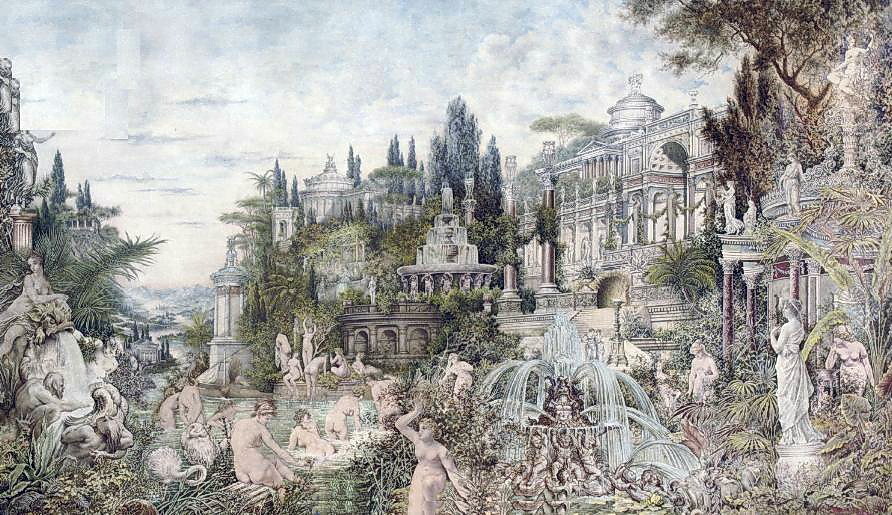What details in the image hint at its overall mood and atmosphere? Several elements in the image are integral in creating the overall mood and atmosphere. The soft pastel color palette, dominated by greens and blues, instills a sense of calm and serenity. The lush gardens, brimming with various plants and flowers, add to the tranquil and refreshing ambiance.

The presence of elaborately detailed statues and dynamic fountains introduces a sense of timeless elegance and refined artistry. The grand palace, with its intricate Rococo-style detailing, exudes majesty and opulence. Together, these components craft a scene that feels both peaceful and fantastical, encouraging viewers to lose themselves in its beauty and intricacy. What could be the historical context or background of such a palace and garden? The palace and garden depicted in the image could be inspired by European architectural and garden design traditions from the 18th century, particularly those associated with the Rococo and Baroque periods. During this era, grand palaces were constructed as symbols of royal or aristocratic power and wealth. These opulent residences were often surrounded by meticulously designed gardens that served as both personal retreats and venues for social gatherings.

Such estates were not only places of residence but also expressions of artistic and cultural sophistication. The extensive use of sculptures, fountains, and ornamental plants in the gardens reflects the era's fascination with classical art, mythology, and the harmonious blend of nature and human creativity. The palace itself, with its intricate design and elaborate decorations, exemplifies the Rococo style's emphasis on elegance, lightness, and ornamental beauty.

Historically, these settings were designed to impress and inspire awe, serving as embodiments of the owner's status and taste. They were often the backdrop for lavish events, intellectual salons, and private moments of contemplation, capturing the essence of a bygone era where art, nature, and architecture seamlessly converged. If you could transport yourself into this scene for just one day, what would you do? If I could step into this enchanting scene, I would begin my day by exploring the lush gardens, taking in the fragrance of blooming flowers and the sound of birds chirping. I would admire the intricate statues, imagining the stories they represent, and spend some time by the fountains, feeling the cool mist on my face and listening to the soothing sound of water.

As the day progresses, I would make my way to the grand palace, where I would marvel at the ornate architecture and detailed decorations. I would venture through its luxurious halls and chambers, perhaps discovering hidden rooms filled with ancient books and artifacts.

In the afternoon, I would attend a splendid outdoor feast in the garden, where tables are laden with delicious food and drink. I would join the other guests in lively conversation, sharing stories and laughter under the shade of towering trees.

As evening falls, I would participate in a grand masquerade ball held in the palace's magnificent ballroom. Dressed in elegant attire and a mask, I would dance under the glittering chandeliers, swept up in the magic and romance of the night. As the stars twinkle above, I would take a moment to step out onto a balcony, overlooking the serene gardens illuminated by moonlight, savoring the enchantment of this unforgettable day. 